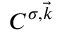Convert formula to latex. <formula><loc_0><loc_0><loc_500><loc_500>C ^ { \sigma , \vec { k } }</formula> 